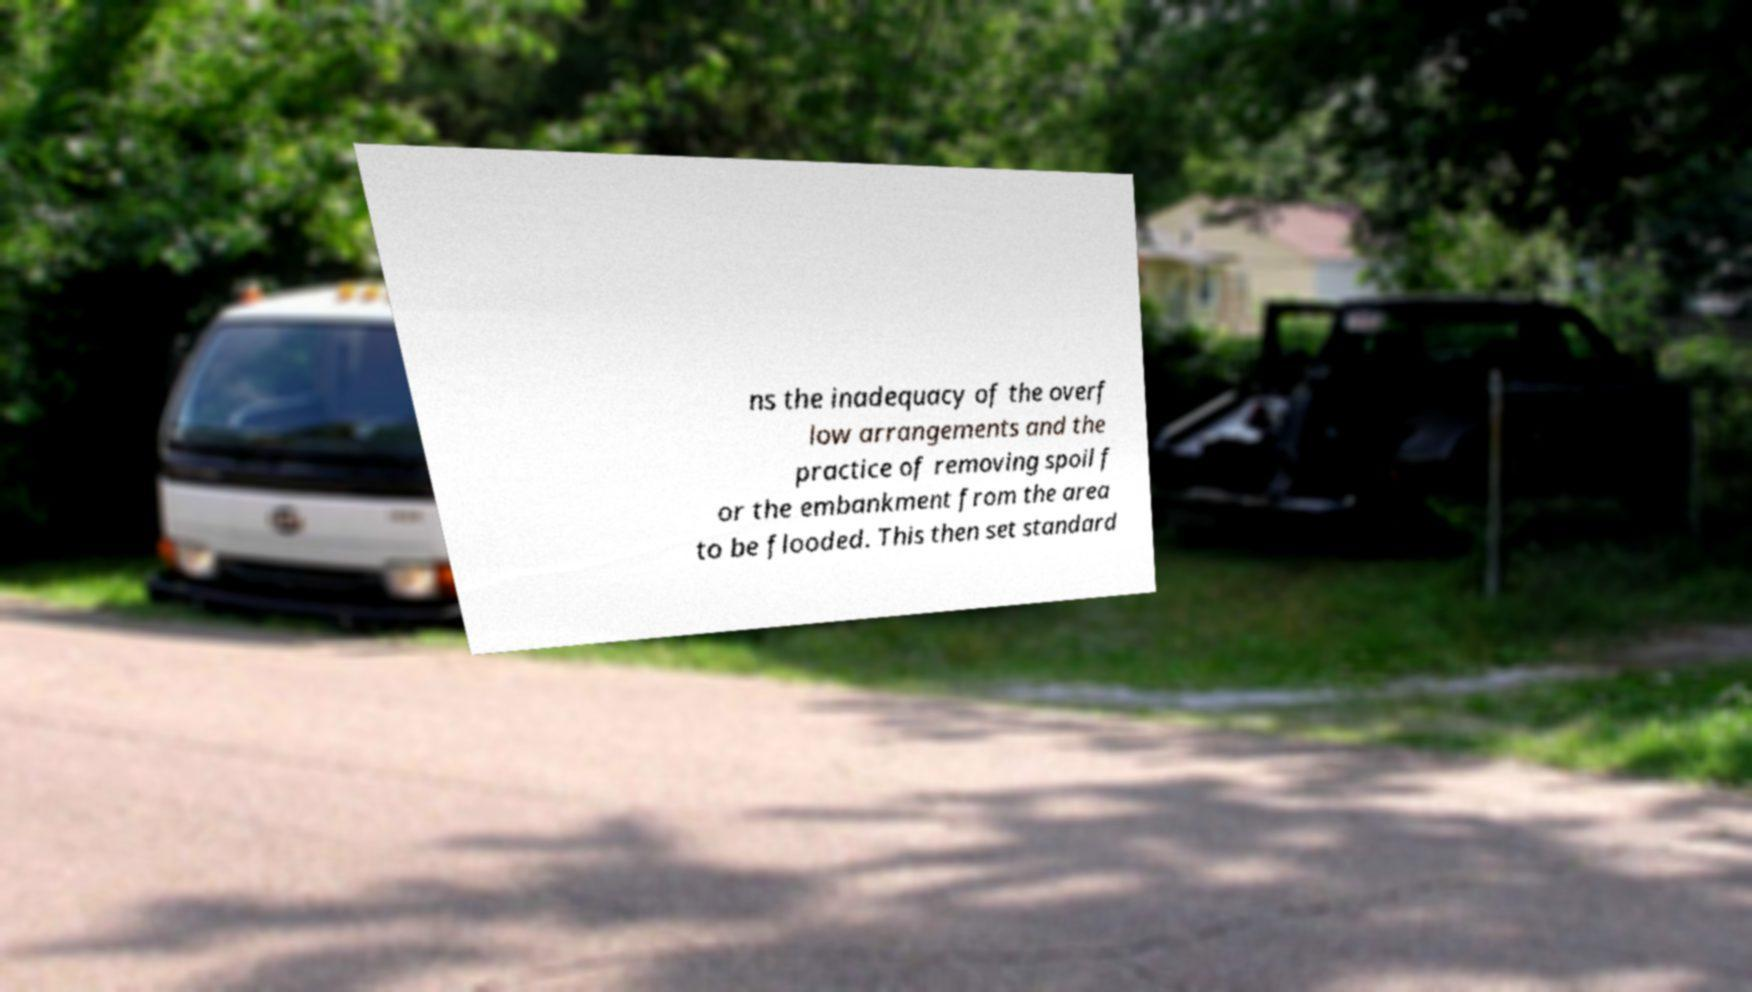I need the written content from this picture converted into text. Can you do that? ns the inadequacy of the overf low arrangements and the practice of removing spoil f or the embankment from the area to be flooded. This then set standard 